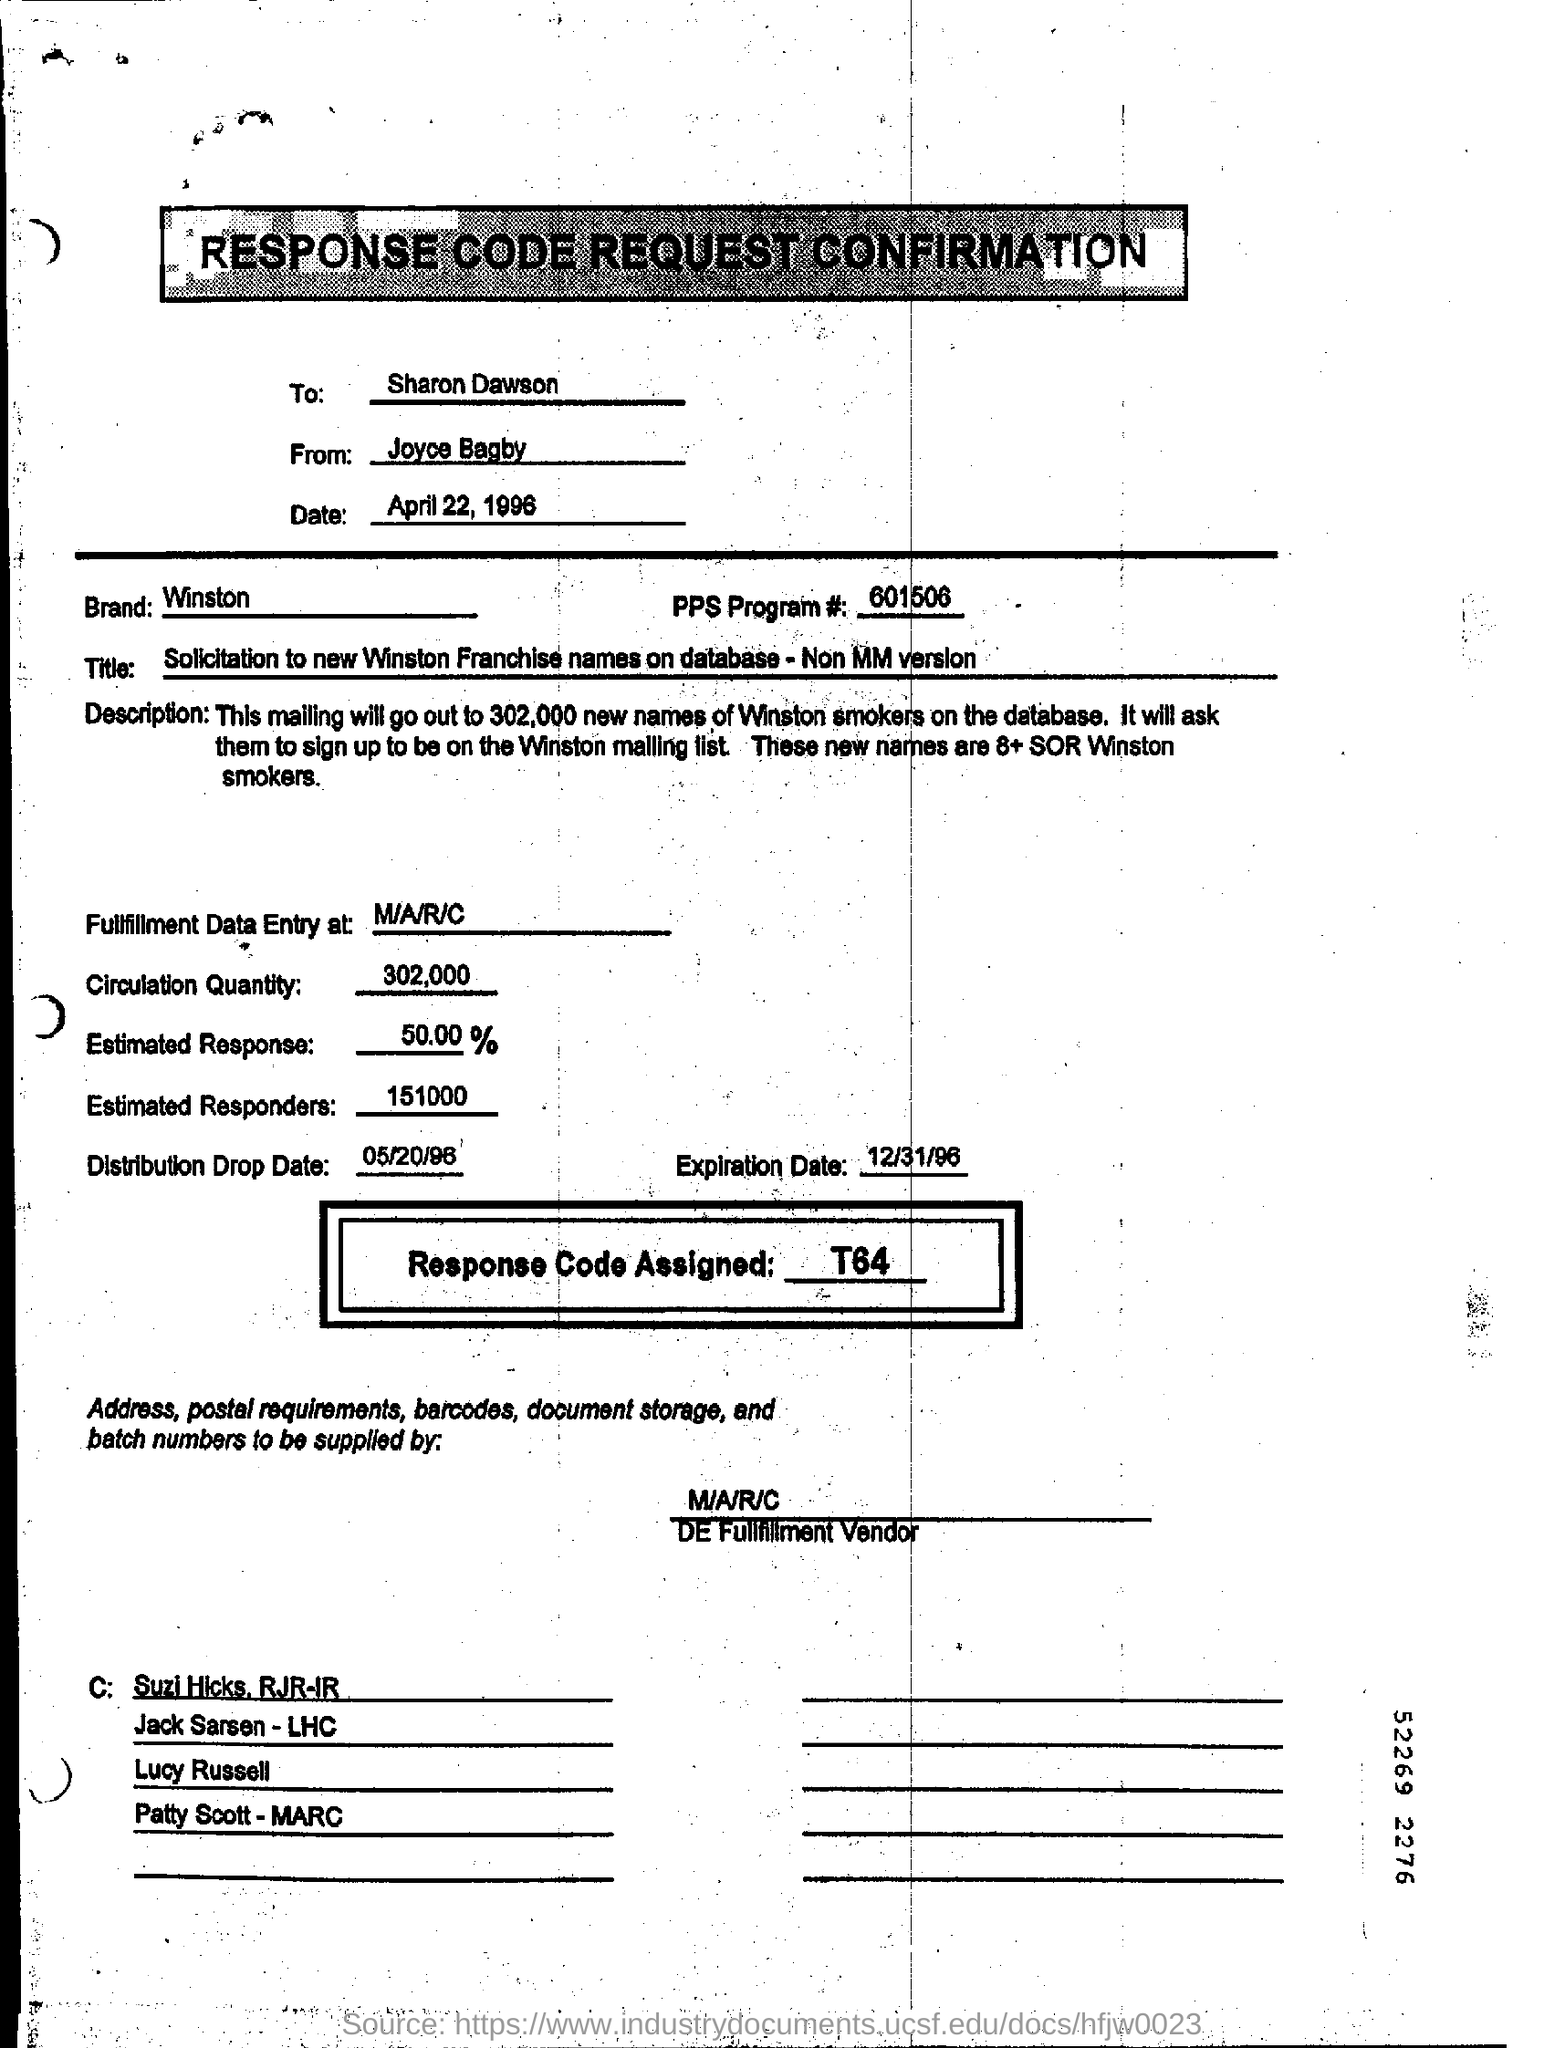What is the date in the RESPONSE CODE REQUEST CONFIRMATION ?
Ensure brevity in your answer.  April 22, 1996. What is the code for the pps program#?
Your answer should be very brief. 601506. How much quantity for the circulation ?
Give a very brief answer. 302,000. What is the distribution drop date?
Offer a very short reply. 05/20/96. 